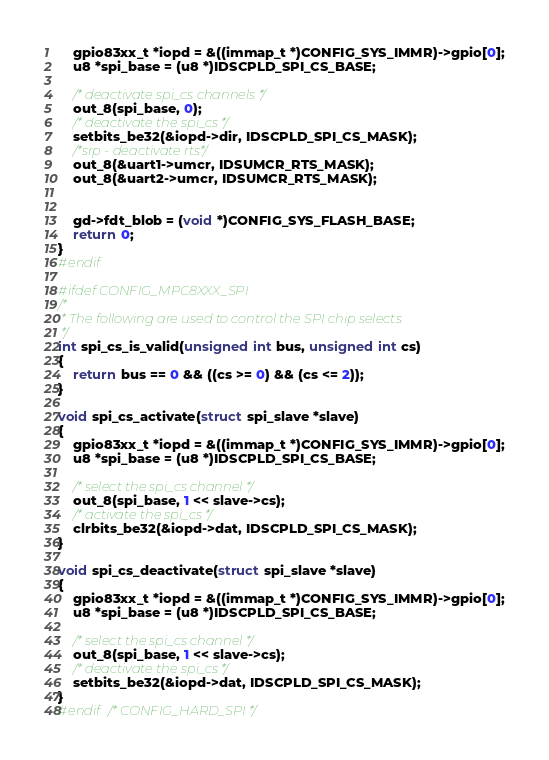<code> <loc_0><loc_0><loc_500><loc_500><_C_>	gpio83xx_t *iopd = &((immap_t *)CONFIG_SYS_IMMR)->gpio[0];
	u8 *spi_base = (u8 *)IDSCPLD_SPI_CS_BASE;

	/* deactivate spi_cs channels */
	out_8(spi_base, 0);
	/* deactivate the spi_cs */
	setbits_be32(&iopd->dir, IDSCPLD_SPI_CS_MASK);
	/*srp - deactivate rts*/
	out_8(&uart1->umcr, IDSUMCR_RTS_MASK);
	out_8(&uart2->umcr, IDSUMCR_RTS_MASK);


	gd->fdt_blob = (void *)CONFIG_SYS_FLASH_BASE;
	return 0;
}
#endif

#ifdef CONFIG_MPC8XXX_SPI
/*
 * The following are used to control the SPI chip selects
 */
int spi_cs_is_valid(unsigned int bus, unsigned int cs)
{
	return bus == 0 && ((cs >= 0) && (cs <= 2));
}

void spi_cs_activate(struct spi_slave *slave)
{
	gpio83xx_t *iopd = &((immap_t *)CONFIG_SYS_IMMR)->gpio[0];
	u8 *spi_base = (u8 *)IDSCPLD_SPI_CS_BASE;

	/* select the spi_cs channel */
	out_8(spi_base, 1 << slave->cs);
	/* activate the spi_cs */
	clrbits_be32(&iopd->dat, IDSCPLD_SPI_CS_MASK);
}

void spi_cs_deactivate(struct spi_slave *slave)
{
	gpio83xx_t *iopd = &((immap_t *)CONFIG_SYS_IMMR)->gpio[0];
	u8 *spi_base = (u8 *)IDSCPLD_SPI_CS_BASE;

	/* select the spi_cs channel */
	out_8(spi_base, 1 << slave->cs);
	/* deactivate the spi_cs */
	setbits_be32(&iopd->dat, IDSCPLD_SPI_CS_MASK);
}
#endif /* CONFIG_HARD_SPI */
</code> 